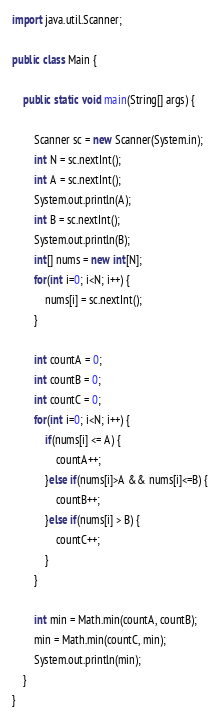Convert code to text. <code><loc_0><loc_0><loc_500><loc_500><_Java_>import java.util.Scanner;

public class Main {

	public static void main(String[] args) {
		
		Scanner sc = new Scanner(System.in);
		int N = sc.nextInt();
		int A = sc.nextInt();
		System.out.println(A);
		int B = sc.nextInt();
		System.out.println(B);
		int[] nums = new int[N];
		for(int i=0; i<N; i++) {
			nums[i] = sc.nextInt();
		}
		
		int countA = 0;
		int countB = 0;
		int countC = 0;
		for(int i=0; i<N; i++) {
			if(nums[i] <= A) {
				countA++;
			}else if(nums[i]>A && nums[i]<=B) {
				countB++;
			}else if(nums[i] > B) {
				countC++;
			}
		}
		
		int min = Math.min(countA, countB);
		min = Math.min(countC, min);
		System.out.println(min);
	}
}
</code> 